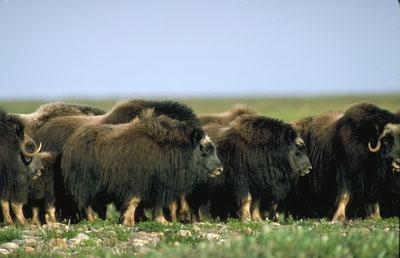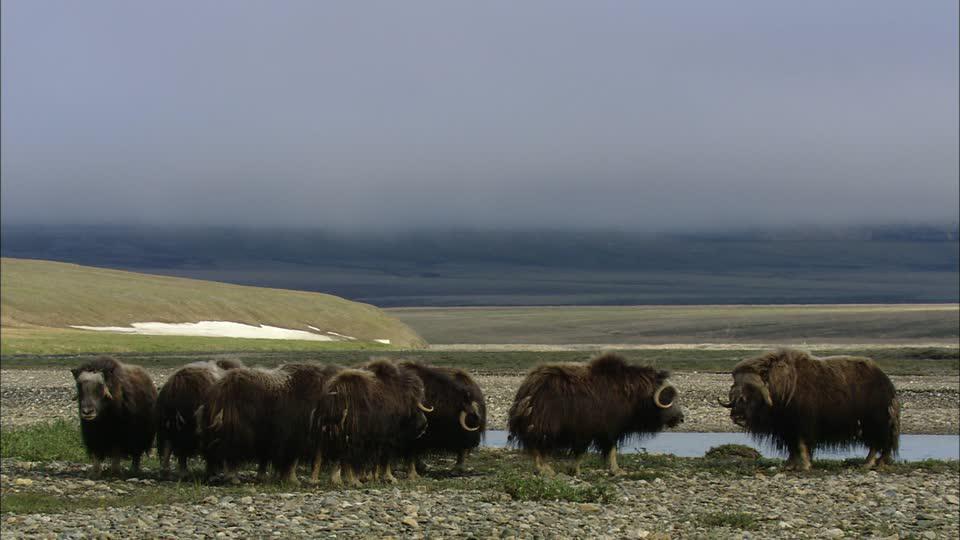The first image is the image on the left, the second image is the image on the right. Examine the images to the left and right. Is the description "There are no more than three yaks in the left image." accurate? Answer yes or no. No. 